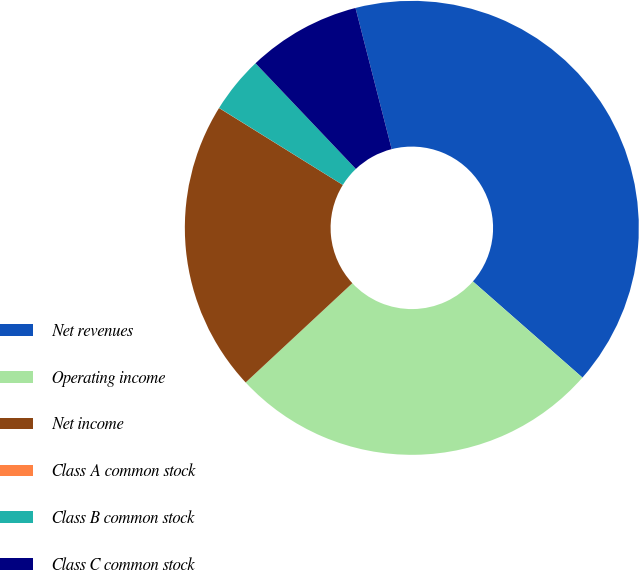Convert chart to OTSL. <chart><loc_0><loc_0><loc_500><loc_500><pie_chart><fcel>Net revenues<fcel>Operating income<fcel>Net income<fcel>Class A common stock<fcel>Class B common stock<fcel>Class C common stock<nl><fcel>40.46%<fcel>26.61%<fcel>20.78%<fcel>0.01%<fcel>4.05%<fcel>8.1%<nl></chart> 